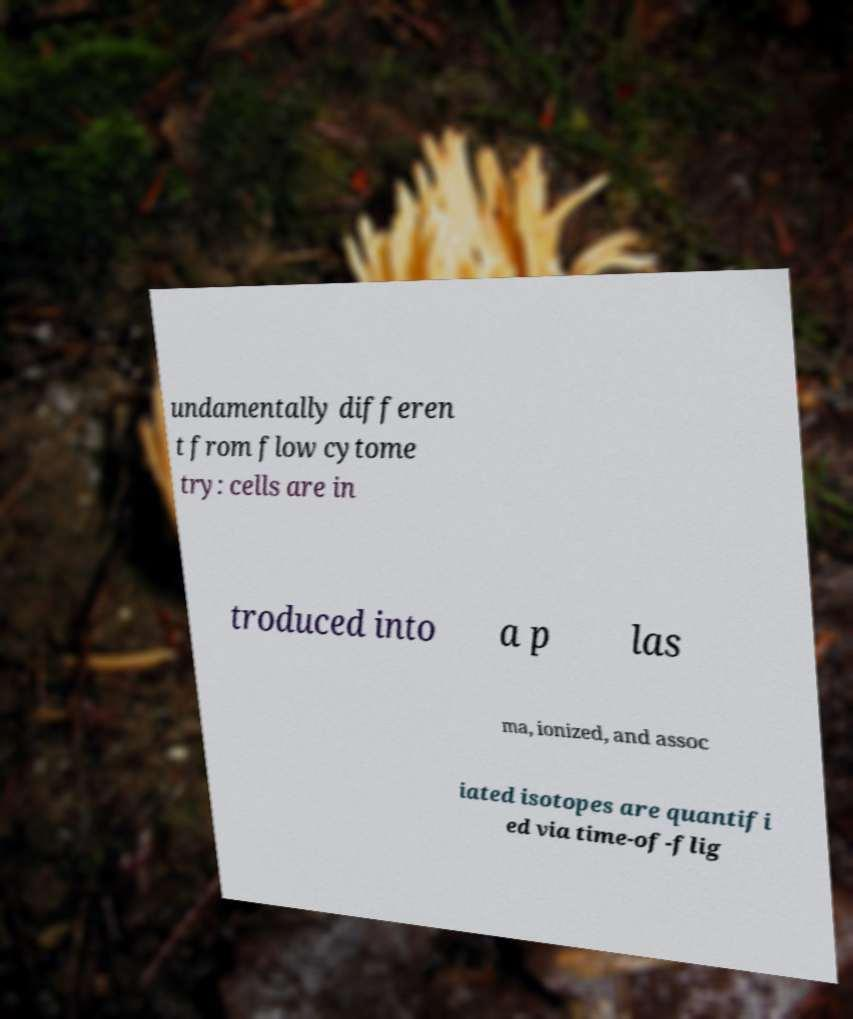For documentation purposes, I need the text within this image transcribed. Could you provide that? undamentally differen t from flow cytome try: cells are in troduced into a p las ma, ionized, and assoc iated isotopes are quantifi ed via time-of-flig 